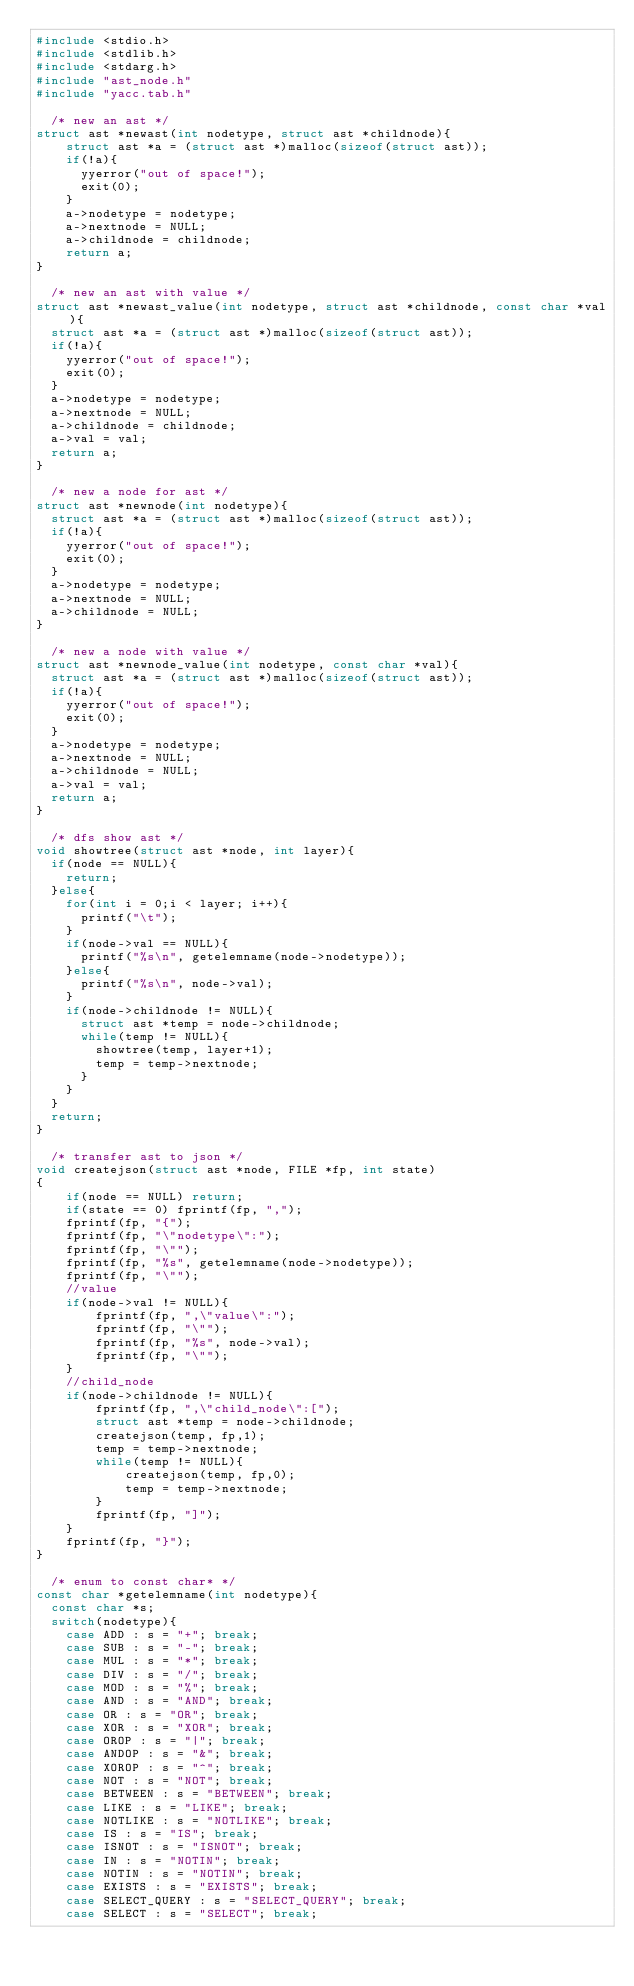<code> <loc_0><loc_0><loc_500><loc_500><_C_>#include <stdio.h>
#include <stdlib.h>
#include <stdarg.h>
#include "ast_node.h"
#include "yacc.tab.h"

  /* new an ast */
struct ast *newast(int nodetype, struct ast *childnode){
    struct ast *a = (struct ast *)malloc(sizeof(struct ast));
    if(!a){
      yyerror("out of space!");
      exit(0);
    }
    a->nodetype = nodetype;
    a->nextnode = NULL;
    a->childnode = childnode;
    return a;
}

  /* new an ast with value */
struct ast *newast_value(int nodetype, struct ast *childnode, const char *val){
  struct ast *a = (struct ast *)malloc(sizeof(struct ast));
  if(!a){
    yyerror("out of space!");
    exit(0);
  }
  a->nodetype = nodetype;
  a->nextnode = NULL;
  a->childnode = childnode;
  a->val = val;
  return a;
}

  /* new a node for ast */
struct ast *newnode(int nodetype){
  struct ast *a = (struct ast *)malloc(sizeof(struct ast));
  if(!a){
    yyerror("out of space!");
    exit(0);
  }
  a->nodetype = nodetype;
  a->nextnode = NULL;
  a->childnode = NULL;
}

  /* new a node with value */
struct ast *newnode_value(int nodetype, const char *val){
  struct ast *a = (struct ast *)malloc(sizeof(struct ast));
  if(!a){
    yyerror("out of space!");
    exit(0);
  }
  a->nodetype = nodetype;
  a->nextnode = NULL;
  a->childnode = NULL;
  a->val = val;
  return a;
}

  /* dfs show ast */
void showtree(struct ast *node, int layer){
  if(node == NULL){
    return;
  }else{
    for(int i = 0;i < layer; i++){
      printf("\t");
    }
    if(node->val == NULL){
      printf("%s\n", getelemname(node->nodetype));
    }else{
      printf("%s\n", node->val);
    }
    if(node->childnode != NULL){
      struct ast *temp = node->childnode;
      while(temp != NULL){
        showtree(temp, layer+1);
        temp = temp->nextnode;
      }
    }
  }
  return;
}

  /* transfer ast to json */
void createjson(struct ast *node, FILE *fp, int state)
{
    if(node == NULL) return;
    if(state == 0) fprintf(fp, ",");
    fprintf(fp, "{");
    fprintf(fp, "\"nodetype\":");
    fprintf(fp, "\"");
    fprintf(fp, "%s", getelemname(node->nodetype));
    fprintf(fp, "\"");
    //value
    if(node->val != NULL){
        fprintf(fp, ",\"value\":");
        fprintf(fp, "\"");
        fprintf(fp, "%s", node->val);
        fprintf(fp, "\"");
    }
    //child_node
    if(node->childnode != NULL){
        fprintf(fp, ",\"child_node\":[");
        struct ast *temp = node->childnode;
        createjson(temp, fp,1);
        temp = temp->nextnode;
        while(temp != NULL){
            createjson(temp, fp,0);
            temp = temp->nextnode;
        }
        fprintf(fp, "]");
    }
    fprintf(fp, "}");
}

  /* enum to const char* */
const char *getelemname(int nodetype){
  const char *s;
  switch(nodetype){
    case ADD : s = "+"; break;
    case SUB : s = "-"; break;
    case MUL : s = "*"; break;
    case DIV : s = "/"; break;
    case MOD : s = "%"; break;
    case AND : s = "AND"; break;
    case OR : s = "OR"; break;
    case XOR : s = "XOR"; break;
    case OROP : s = "|"; break;
    case ANDOP : s = "&"; break;
    case XOROP : s = "^"; break;
    case NOT : s = "NOT"; break;
    case BETWEEN : s = "BETWEEN"; break;
    case LIKE : s = "LIKE"; break;
    case NOTLIKE : s = "NOTLIKE"; break;
    case IS : s = "IS"; break;
    case ISNOT : s = "ISNOT"; break;
    case IN : s = "NOTIN"; break;
    case NOTIN : s = "NOTIN"; break;
    case EXISTS : s = "EXISTS"; break;
    case SELECT_QUERY : s = "SELECT_QUERY"; break;
    case SELECT : s = "SELECT"; break;</code> 